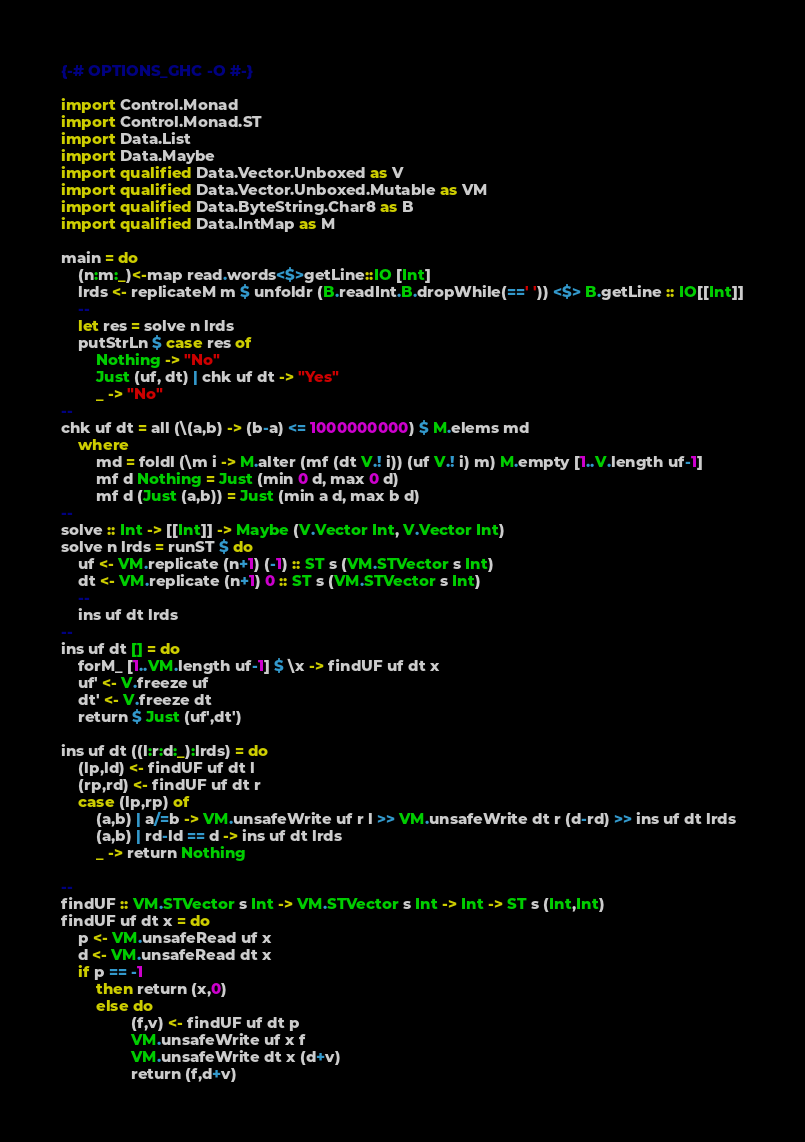<code> <loc_0><loc_0><loc_500><loc_500><_Haskell_>{-# OPTIONS_GHC -O #-}

import Control.Monad
import Control.Monad.ST
import Data.List
import Data.Maybe
import qualified Data.Vector.Unboxed as V
import qualified Data.Vector.Unboxed.Mutable as VM
import qualified Data.ByteString.Char8 as B
import qualified Data.IntMap as M

main = do
    (n:m:_)<-map read.words<$>getLine::IO [Int]
    lrds <- replicateM m $ unfoldr (B.readInt.B.dropWhile(==' ')) <$> B.getLine :: IO[[Int]]
    --
    let res = solve n lrds
    putStrLn $ case res of
        Nothing -> "No"
        Just (uf, dt) | chk uf dt -> "Yes"
        _ -> "No"
--
chk uf dt = all (\(a,b) -> (b-a) <= 1000000000) $ M.elems md
    where
        md = foldl (\m i -> M.alter (mf (dt V.! i)) (uf V.! i) m) M.empty [1..V.length uf-1]
        mf d Nothing = Just (min 0 d, max 0 d)
        mf d (Just (a,b)) = Just (min a d, max b d)
--
solve :: Int -> [[Int]] -> Maybe (V.Vector Int, V.Vector Int)
solve n lrds = runST $ do
    uf <- VM.replicate (n+1) (-1) :: ST s (VM.STVector s Int)
    dt <- VM.replicate (n+1) 0 :: ST s (VM.STVector s Int)
    --
    ins uf dt lrds
--
ins uf dt [] = do
    forM_ [1..VM.length uf-1] $ \x -> findUF uf dt x
    uf' <- V.freeze uf
    dt' <- V.freeze dt
    return $ Just (uf',dt')

ins uf dt ((l:r:d:_):lrds) = do
    (lp,ld) <- findUF uf dt l
    (rp,rd) <- findUF uf dt r
    case (lp,rp) of
        (a,b) | a/=b -> VM.unsafeWrite uf r l >> VM.unsafeWrite dt r (d-rd) >> ins uf dt lrds
        (a,b) | rd-ld == d -> ins uf dt lrds
        _ -> return Nothing

--
findUF :: VM.STVector s Int -> VM.STVector s Int -> Int -> ST s (Int,Int)
findUF uf dt x = do
    p <- VM.unsafeRead uf x
    d <- VM.unsafeRead dt x
    if p == -1
        then return (x,0)
        else do
                (f,v) <- findUF uf dt p
                VM.unsafeWrite uf x f
                VM.unsafeWrite dt x (d+v)
                return (f,d+v)</code> 